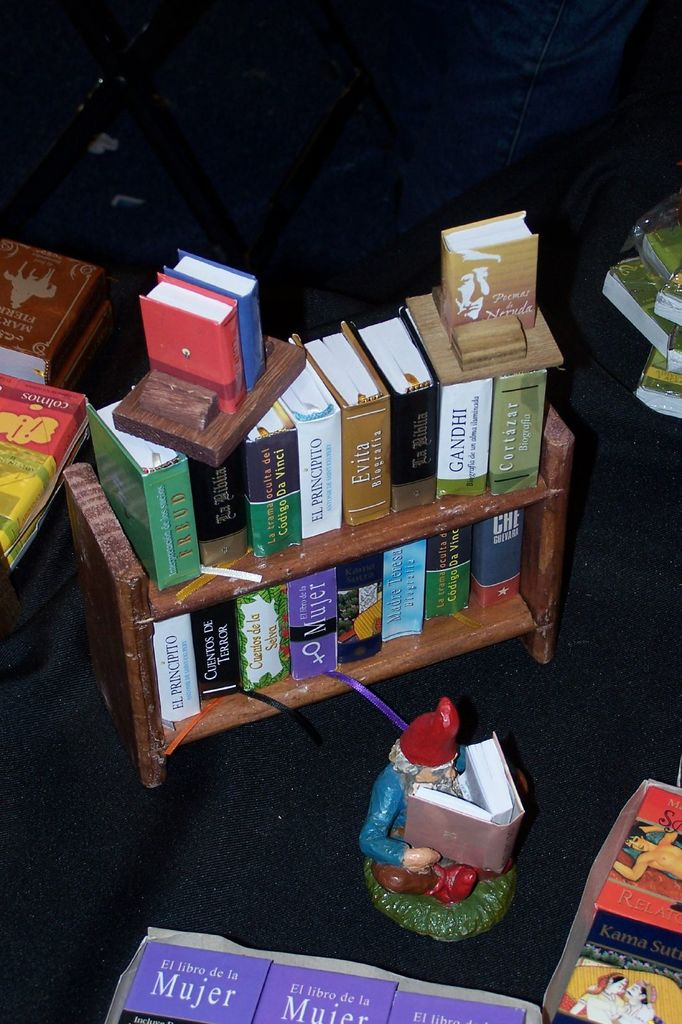What other titles are visible in the image, and what do they suggest about the collection? Other visible titles include 'Gandhi', 'El Principito', and 'Kama Sutra', suggesting a diverse collection that spans various genres and topics from philosophical biographies and classic literature to works on love and relationships. This variety implies a broad appeal, aimed at catering to different reader's interests and cultural backgrounds. 